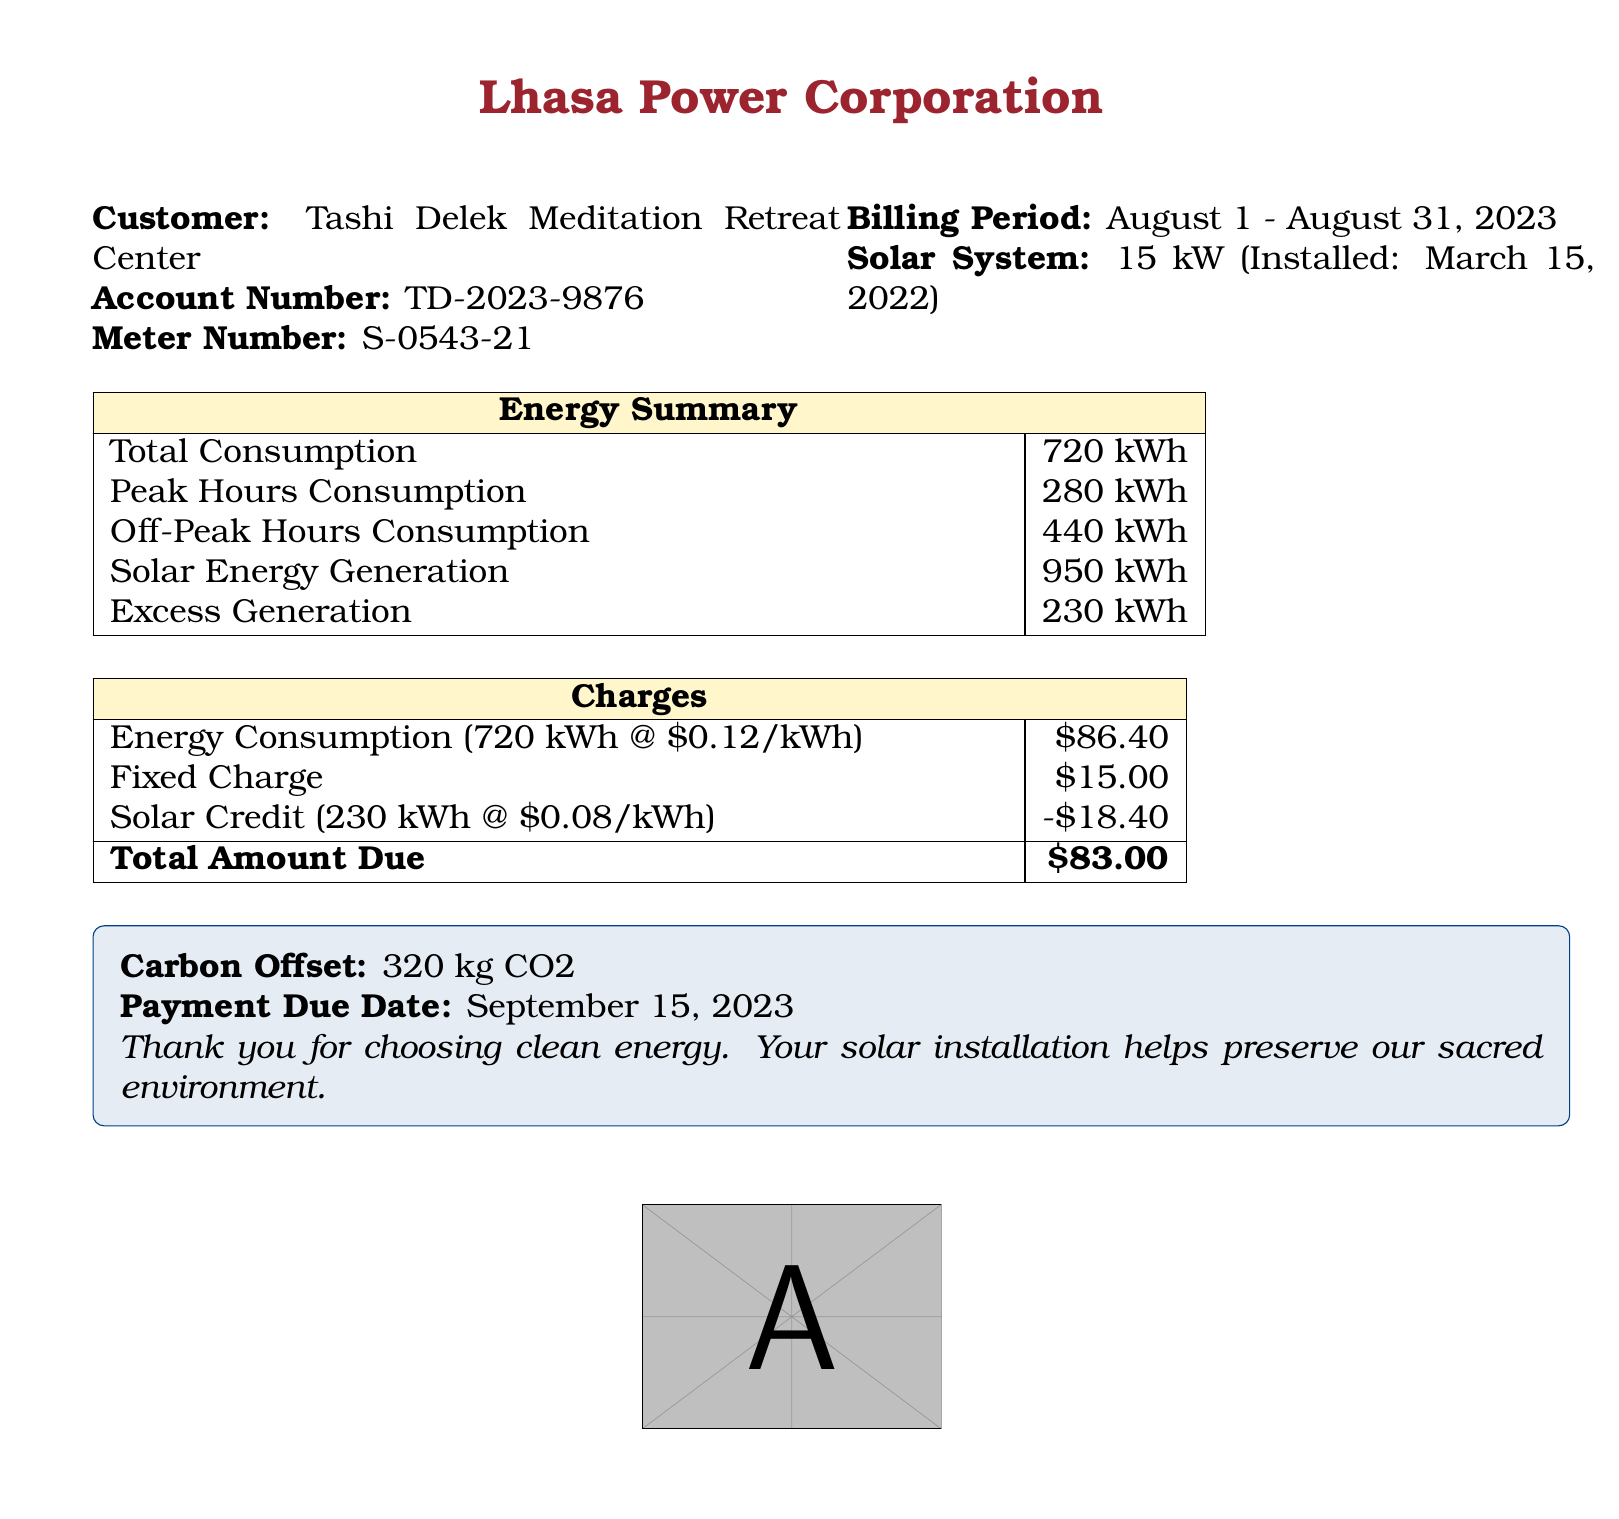What is the customer name? The customer's name is listed at the top of the document under the customer details section.
Answer: Tashi Delek Meditation Retreat Center What is the account number? The account number is provided in the customer details section of the document.
Answer: TD-2023-9876 What is the billing period? The billing period is stated near the top of the document.
Answer: August 1 - August 31, 2023 What is the total consumption of energy? The total energy consumption is shown in the energy summary table.
Answer: 720 kWh How much excess generation is there? The excess generation is mentioned in the summary table of energy.
Answer: 230 kWh What is the total amount due? The total amount due is located in the charges section at the bottom of the document.
Answer: $83.00 What is the solar credit value? The solar credit value is included in the charges table under solar credit.
Answer: -$18.40 What is the fixed charge? The fixed charge is listed in the charges section of the document.
Answer: $15.00 What is the payment due date? The payment due date is stated in the note at the bottom of the document.
Answer: September 15, 2023 